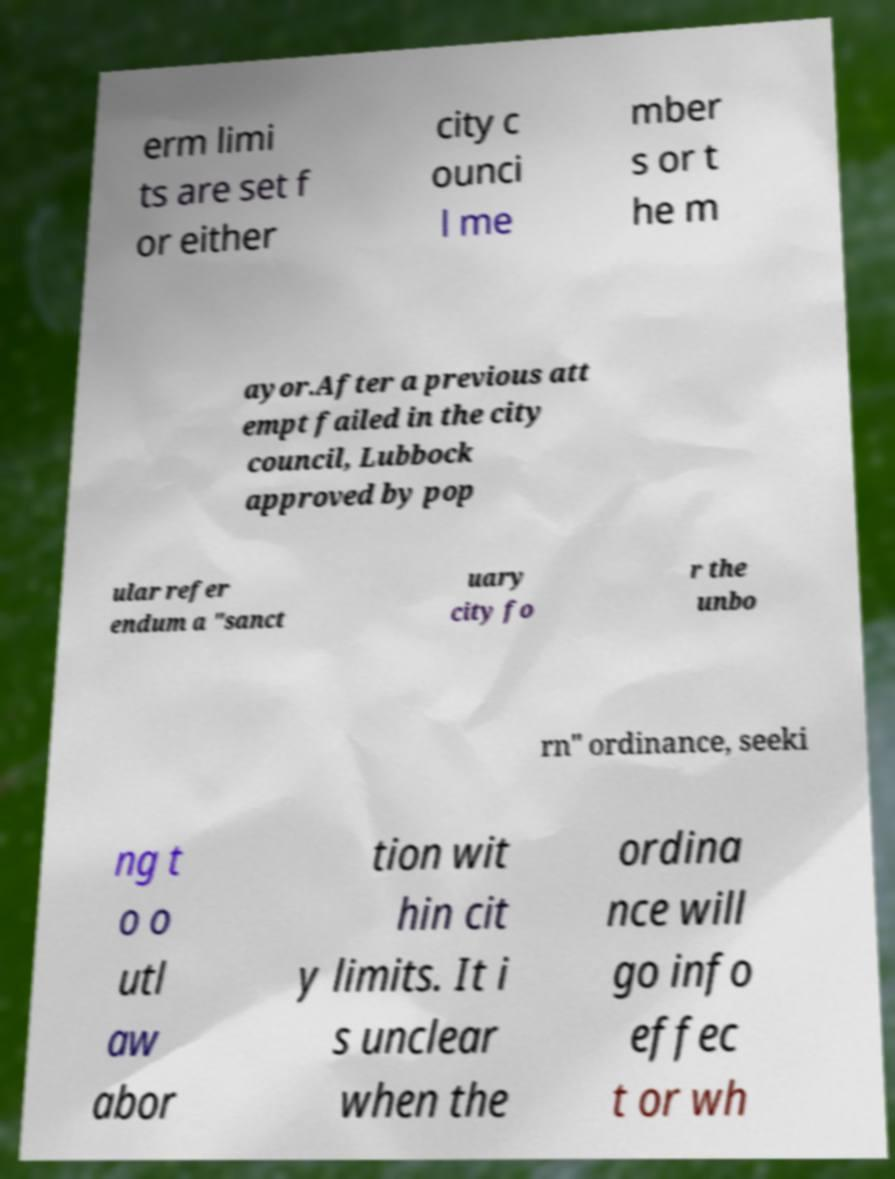Please read and relay the text visible in this image. What does it say? erm limi ts are set f or either city c ounci l me mber s or t he m ayor.After a previous att empt failed in the city council, Lubbock approved by pop ular refer endum a "sanct uary city fo r the unbo rn" ordinance, seeki ng t o o utl aw abor tion wit hin cit y limits. It i s unclear when the ordina nce will go info effec t or wh 